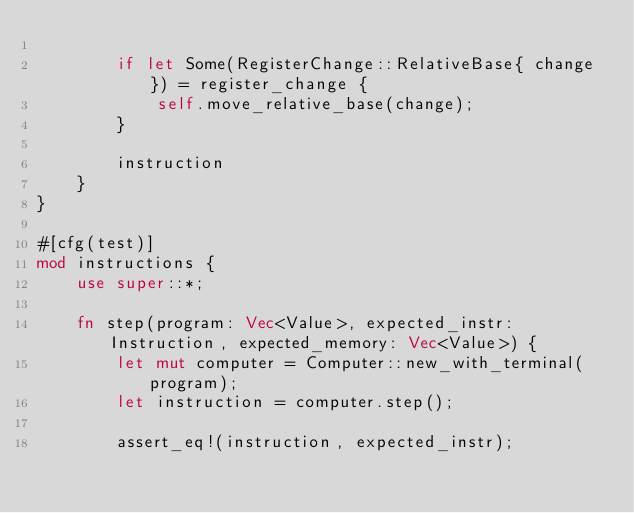Convert code to text. <code><loc_0><loc_0><loc_500><loc_500><_Rust_>
        if let Some(RegisterChange::RelativeBase{ change }) = register_change {
            self.move_relative_base(change);
        }

        instruction
    }
}

#[cfg(test)]
mod instructions {
    use super::*;

    fn step(program: Vec<Value>, expected_instr: Instruction, expected_memory: Vec<Value>) {
        let mut computer = Computer::new_with_terminal(program);
        let instruction = computer.step();

        assert_eq!(instruction, expected_instr);
</code> 